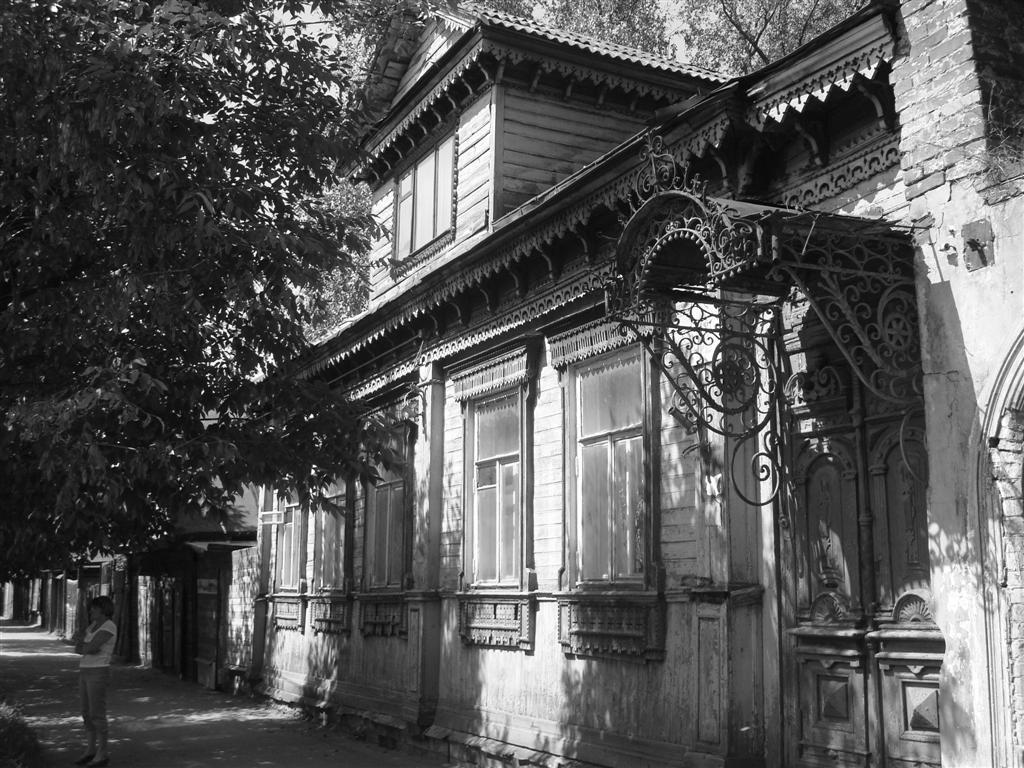How would you summarize this image in a sentence or two? In this image we can see a girl on the road. On the right side of the image there is a building. On the left side we can see a tree. 